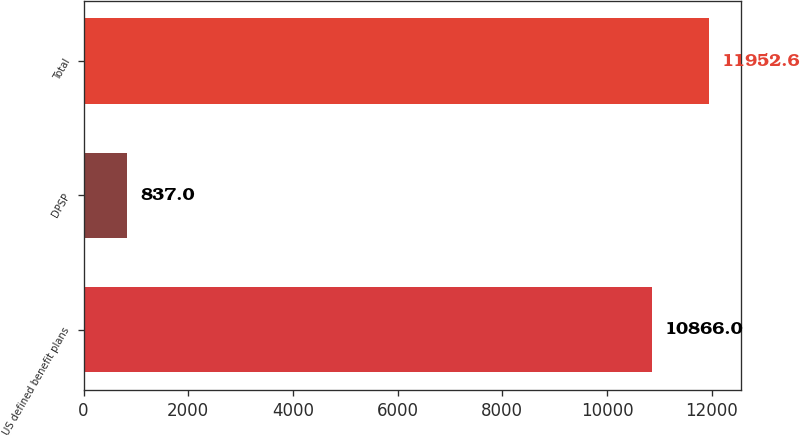Convert chart. <chart><loc_0><loc_0><loc_500><loc_500><bar_chart><fcel>US defined benefit plans<fcel>DPSP<fcel>Total<nl><fcel>10866<fcel>837<fcel>11952.6<nl></chart> 